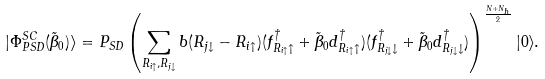Convert formula to latex. <formula><loc_0><loc_0><loc_500><loc_500>| \Phi _ { P S D } ^ { S C } ( \tilde { \beta } _ { 0 } ) \rangle = P _ { S D } \left ( \sum _ { R _ { i \uparrow } , R _ { j \downarrow } } b ( R _ { j \downarrow } - R _ { i \uparrow } ) ( f _ { R _ { i \uparrow } \uparrow } ^ { \dagger } + \tilde { \beta } _ { 0 } d _ { R _ { i \uparrow } \uparrow } ^ { \dagger } ) ( f _ { R _ { j \downarrow } \downarrow } ^ { \dagger } + \tilde { \beta } _ { 0 } d _ { R _ { j \downarrow } \downarrow } ^ { \dagger } ) \right ) ^ { \frac { N + N _ { h } } { 2 } } | 0 \rangle .</formula> 